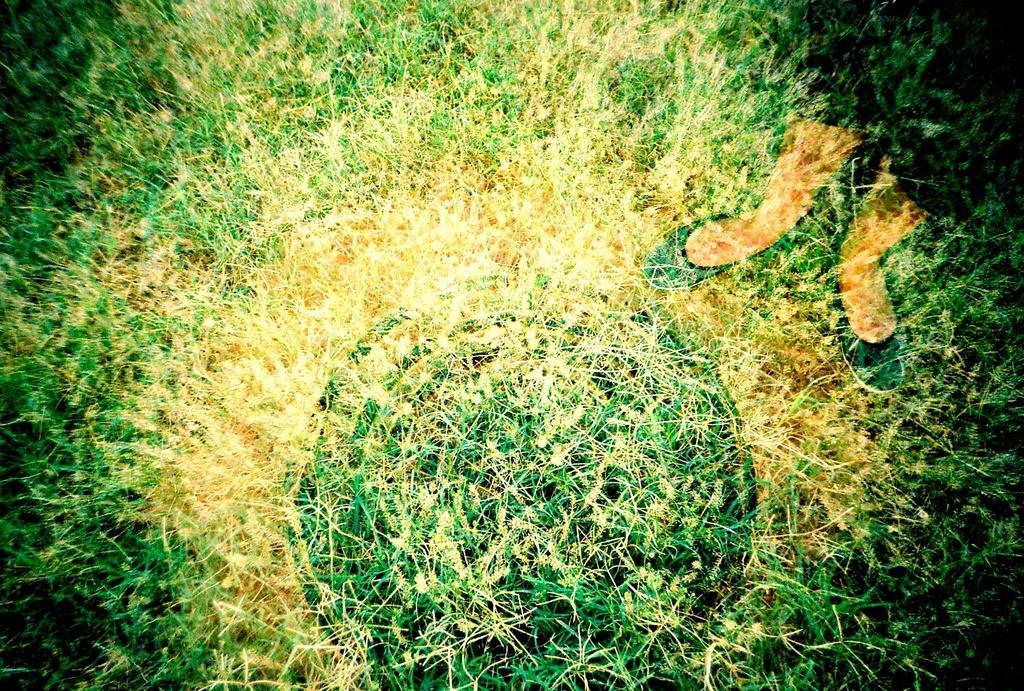Can you describe this image briefly? In the foreground of this edited image, there is grass and on the right, there are legs of a person. 